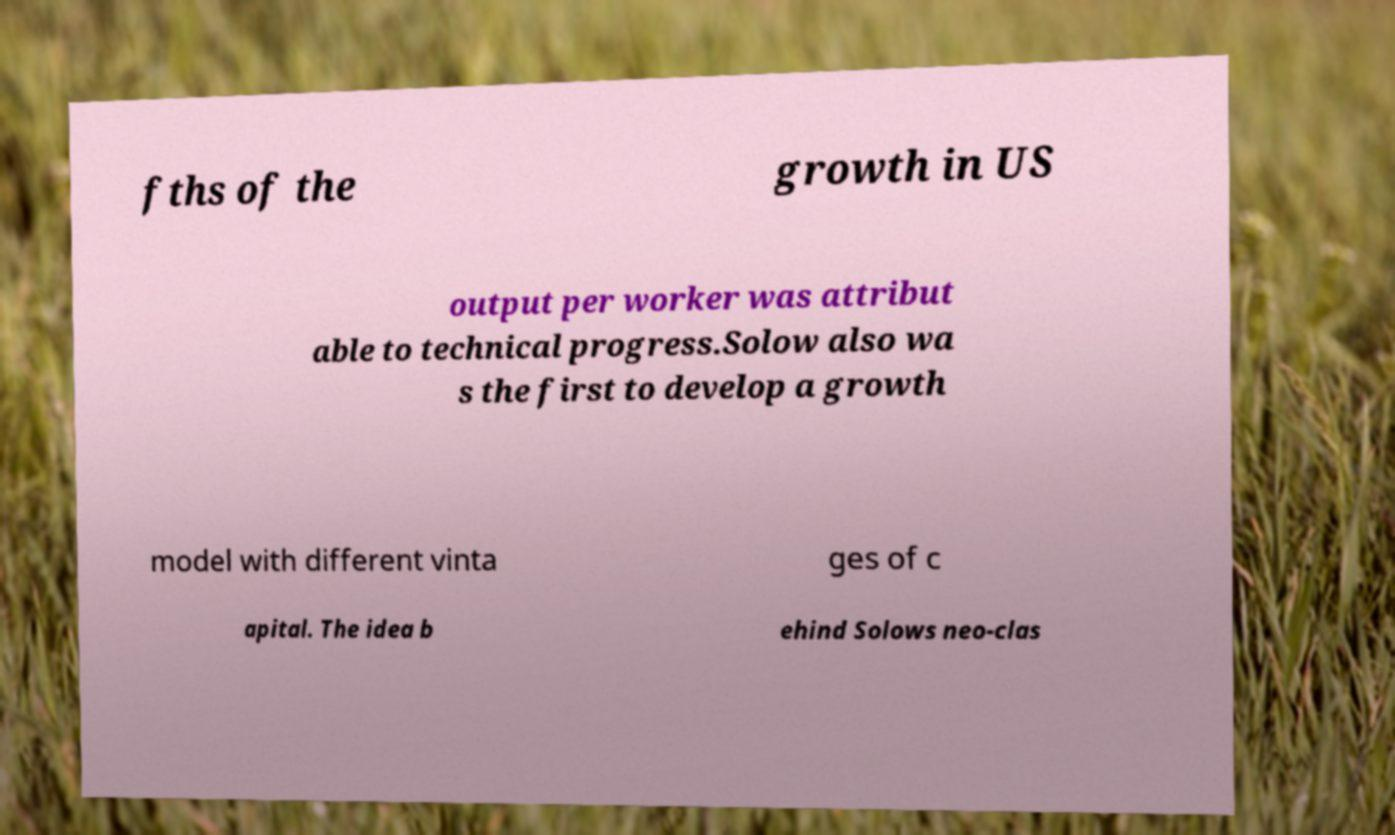Can you accurately transcribe the text from the provided image for me? fths of the growth in US output per worker was attribut able to technical progress.Solow also wa s the first to develop a growth model with different vinta ges of c apital. The idea b ehind Solows neo-clas 